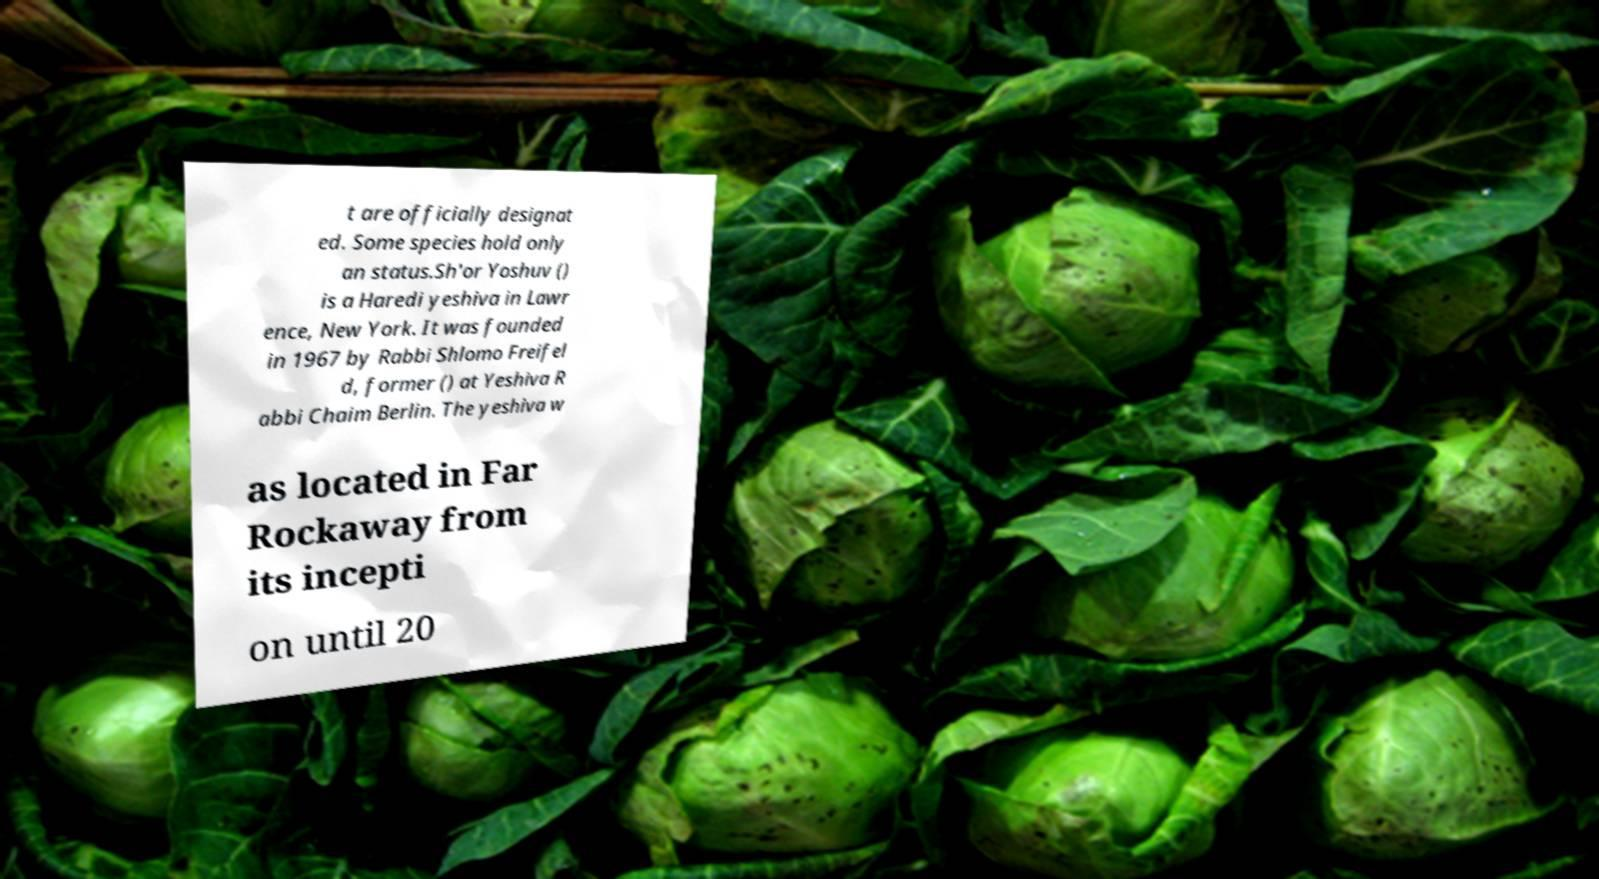Please identify and transcribe the text found in this image. t are officially designat ed. Some species hold only an status.Sh'or Yoshuv () is a Haredi yeshiva in Lawr ence, New York. It was founded in 1967 by Rabbi Shlomo Freifel d, former () at Yeshiva R abbi Chaim Berlin. The yeshiva w as located in Far Rockaway from its incepti on until 20 